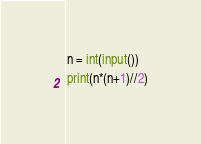Convert code to text. <code><loc_0><loc_0><loc_500><loc_500><_Python_>n = int(input())
print(n*(n+1)//2)</code> 